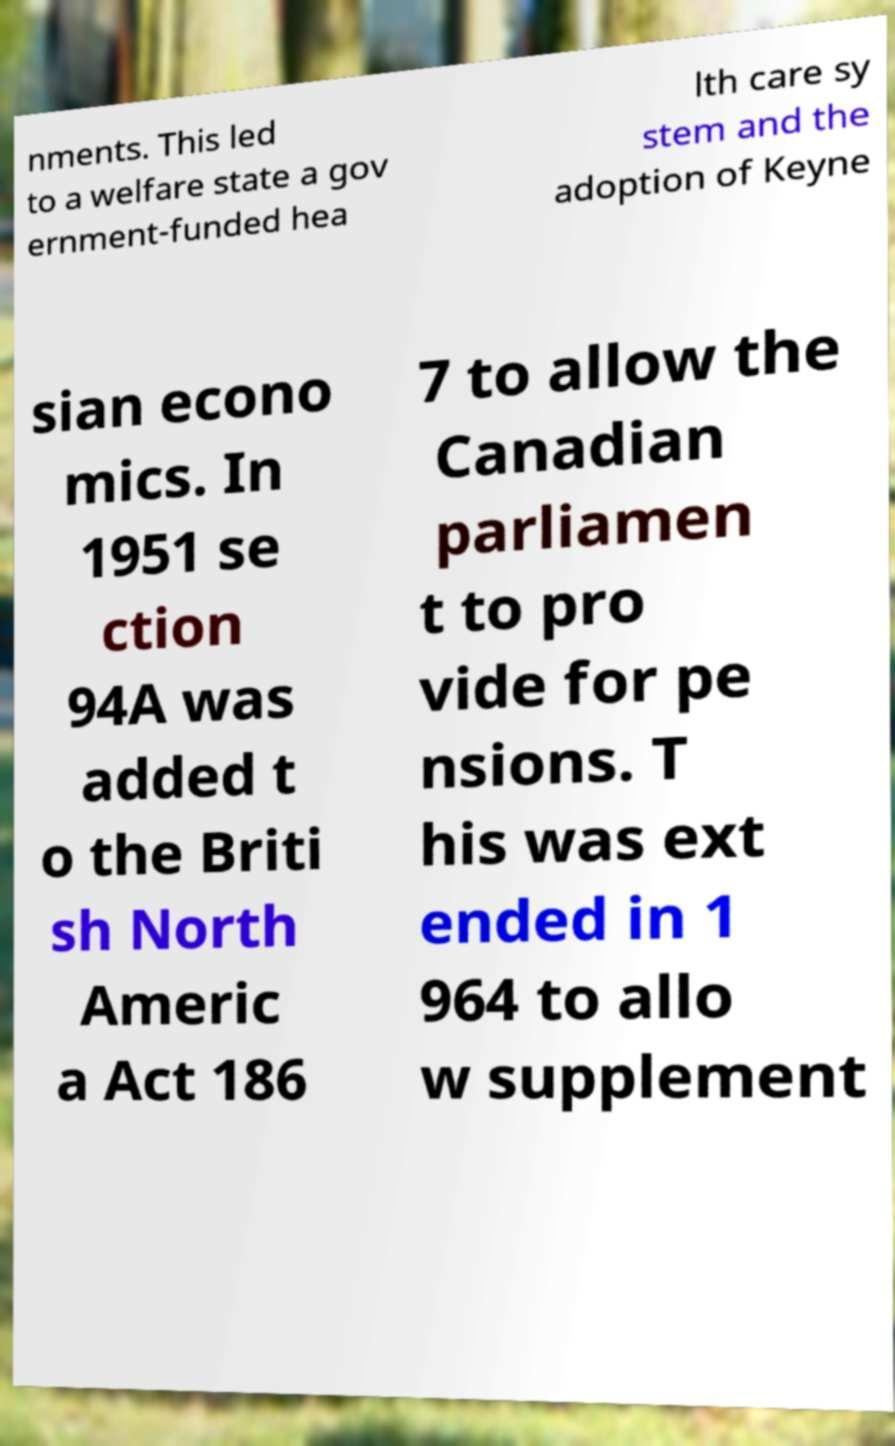For documentation purposes, I need the text within this image transcribed. Could you provide that? nments. This led to a welfare state a gov ernment-funded hea lth care sy stem and the adoption of Keyne sian econo mics. In 1951 se ction 94A was added t o the Briti sh North Americ a Act 186 7 to allow the Canadian parliamen t to pro vide for pe nsions. T his was ext ended in 1 964 to allo w supplement 